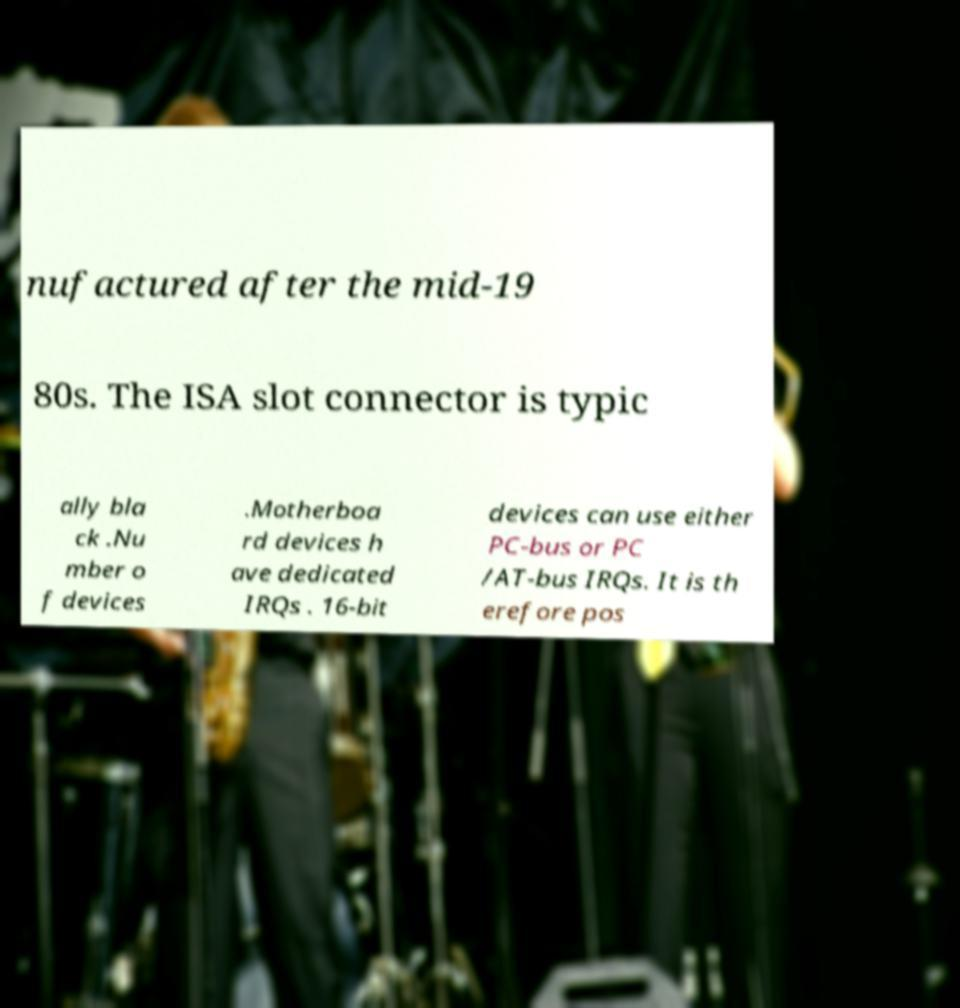Please identify and transcribe the text found in this image. nufactured after the mid-19 80s. The ISA slot connector is typic ally bla ck .Nu mber o f devices .Motherboa rd devices h ave dedicated IRQs . 16-bit devices can use either PC-bus or PC /AT-bus IRQs. It is th erefore pos 